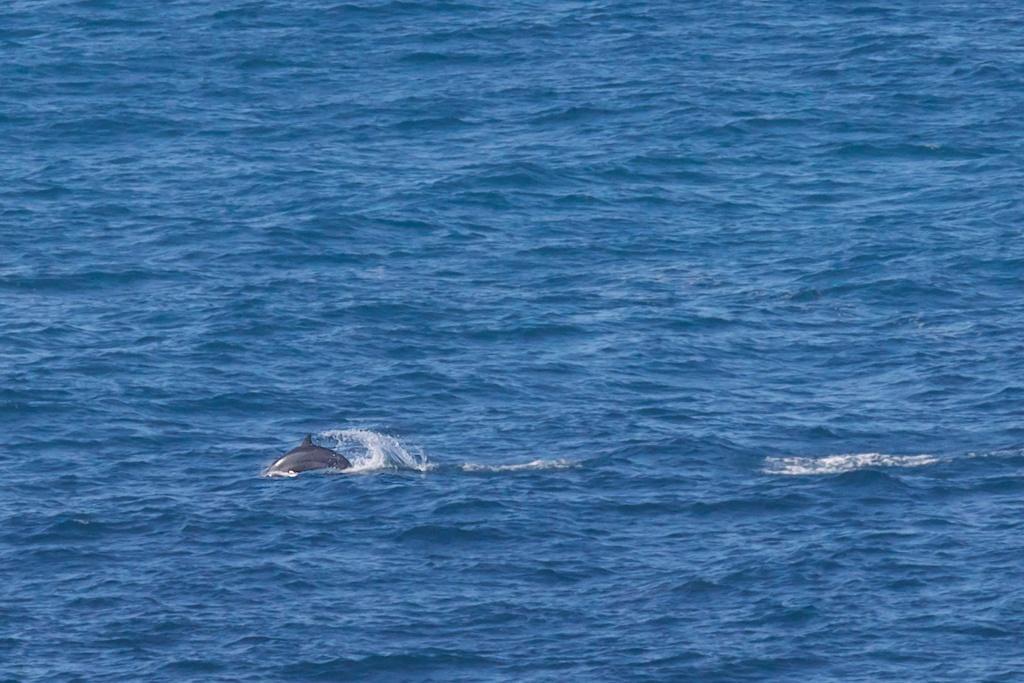In one or two sentences, can you explain what this image depicts? In this image I see the water and I see a dolphin over here. 